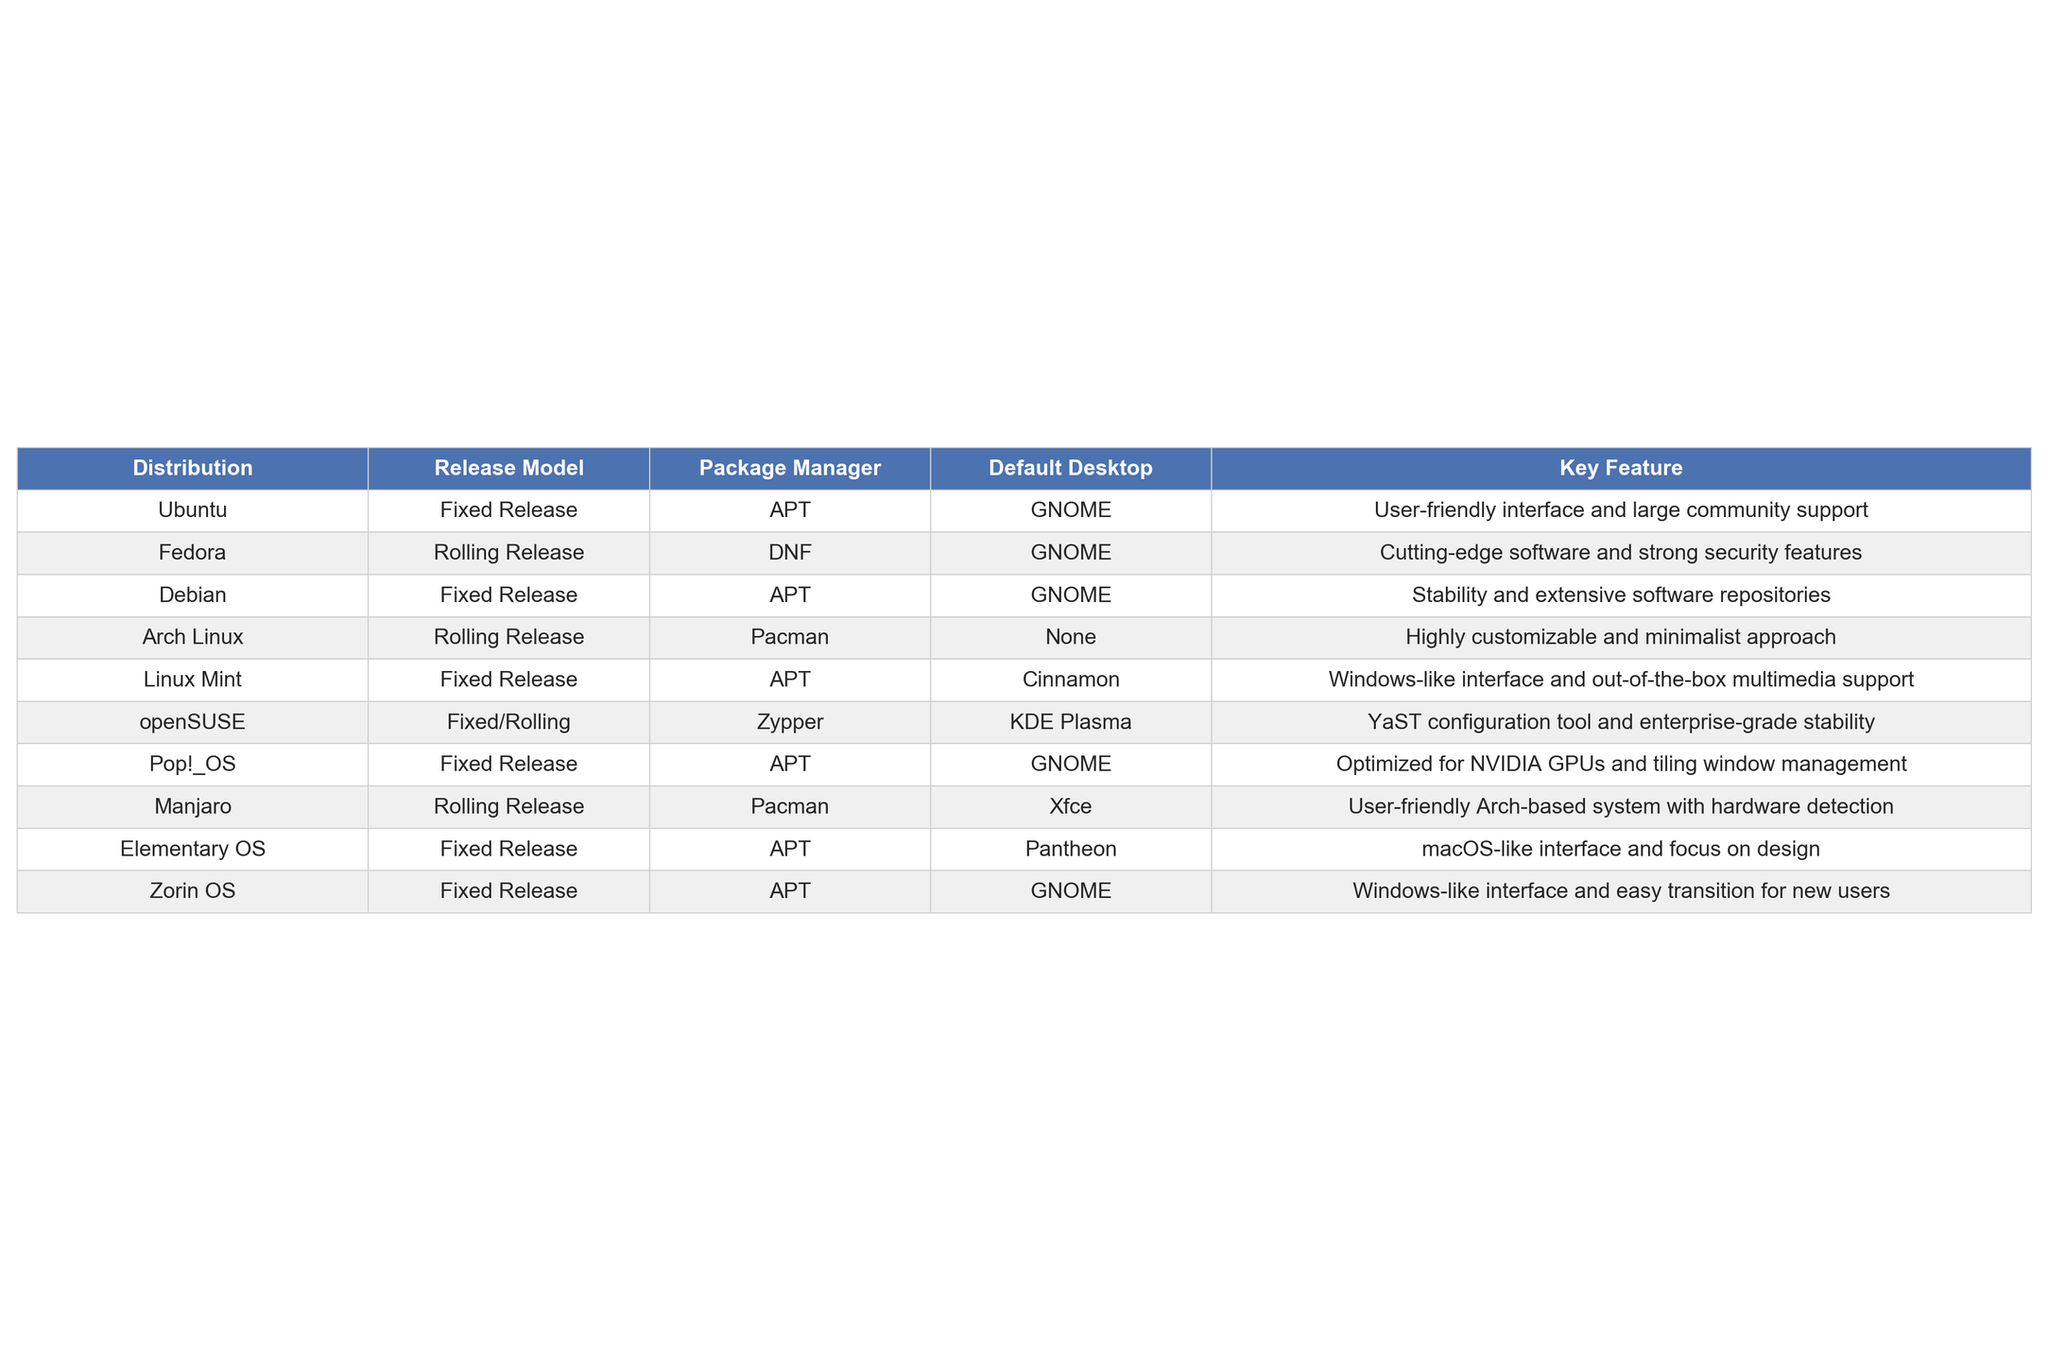What package manager does Linux Mint use? According to the table, Linux Mint uses APT as its package manager.
Answer: APT Which distribution offers a highly customizable and minimalist approach? The table indicates that Arch Linux is the distribution known for its highly customizable and minimalist approach.
Answer: Arch Linux Is Fedora a fixed release distribution? The table clearly states that Fedora follows a rolling release model, so the answer is no.
Answer: No Which two distributions have the GNOME desktop as their default? By reviewing the table, we can identify that Ubuntu and Zorin OS both have GNOME as their default desktop environment.
Answer: Ubuntu and Zorin OS What are the key features of openSUSE? The table specifies that openSUSE's key features include the YaST configuration tool and enterprise-grade stability.
Answer: YaST configuration tool and enterprise-grade stability Which distribution is optimized for NVIDIA GPUs? The table shows that Pop!_OS is optimized specifically for NVIDIA GPUs.
Answer: Pop!_OS If a user prefers a Windows-like interface, which distributions could they consider? The table shows that Linux Mint and Zorin OS both offer a Windows-like interface, making them suitable choices for users who prefer such environments.
Answer: Linux Mint and Zorin OS Which distribution has both a fixed and a rolling release model? The table indicates that openSUSE supports both fixed and rolling release models.
Answer: openSUSE What is the default desktop environment for Manjaro? Based on the table, Manjaro’s default desktop environment is Xfce.
Answer: Xfce Which distribution has a focus on design and is similar to macOS? The table states that Elementary OS is characterized by a macOS-like interface and a focus on design.
Answer: Elementary OS 